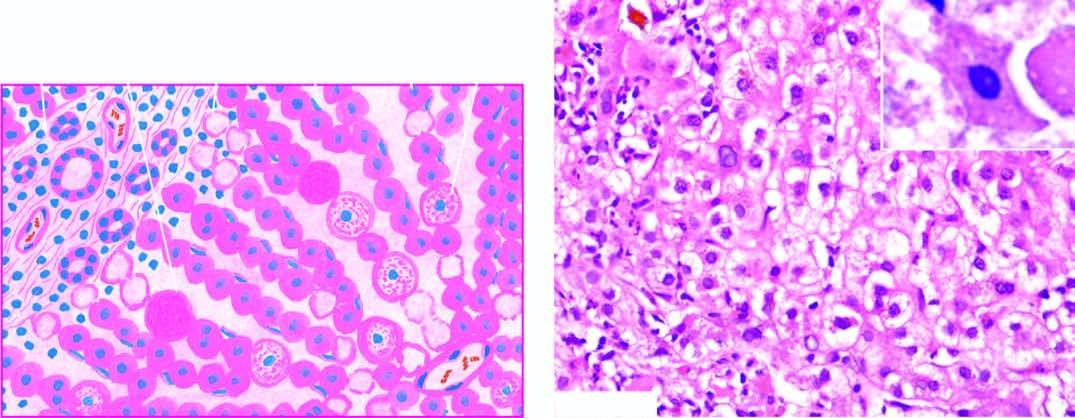what is mild degree of liver cell necrosis seen as?
Answer the question using a single word or phrase. Ballooning degeneration 